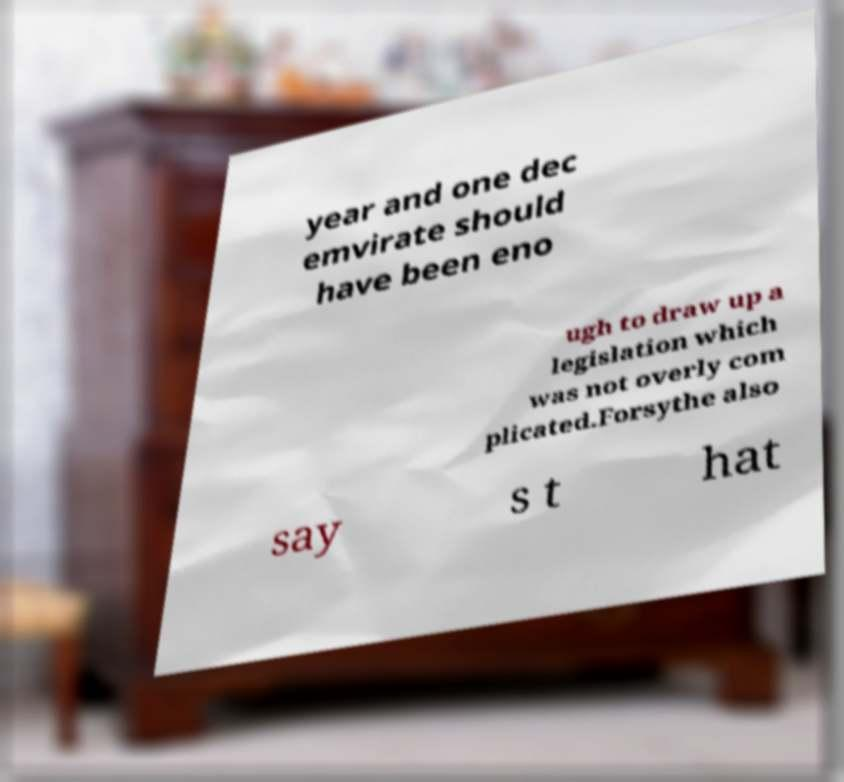What messages or text are displayed in this image? I need them in a readable, typed format. year and one dec emvirate should have been eno ugh to draw up a legislation which was not overly com plicated.Forsythe also say s t hat 